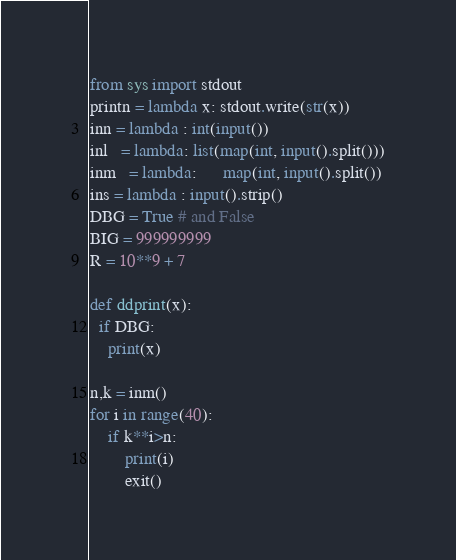Convert code to text. <code><loc_0><loc_0><loc_500><loc_500><_Python_>from sys import stdout
printn = lambda x: stdout.write(str(x))
inn = lambda : int(input())
inl   = lambda: list(map(int, input().split()))
inm   = lambda:      map(int, input().split())
ins = lambda : input().strip()
DBG = True # and False
BIG = 999999999
R = 10**9 + 7

def ddprint(x):
  if DBG:
    print(x)

n,k = inm()
for i in range(40):
    if k**i>n:
        print(i)
        exit()
</code> 